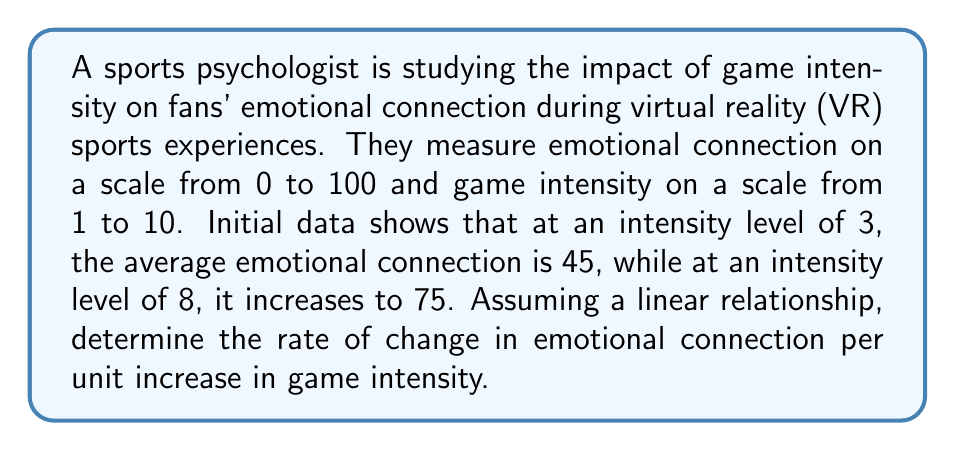What is the answer to this math problem? To solve this problem, we'll use the slope formula for a linear equation:

$$m = \frac{y_2 - y_1}{x_2 - x_1}$$

Where:
$m$ = rate of change (slope)
$(x_1, y_1)$ = first point (intensity level, emotional connection)
$(x_2, y_2)$ = second point (intensity level, emotional connection)

Given:
- Point 1: $(3, 45)$
- Point 2: $(8, 75)$

Let's substitute these values into the slope formula:

$$m = \frac{75 - 45}{8 - 3} = \frac{30}{5}$$

Simplify:

$$m = 6$$

This means that for every 1-unit increase in game intensity, the emotional connection increases by 6 units on average.

To verify, we can use the point-slope form of a linear equation:

$$y - y_1 = m(x - x_1)$$

Substituting our values:

$$y - 45 = 6(x - 3)$$

This equation represents the linear relationship between game intensity and emotional connection.
Answer: 6 units per intensity level 